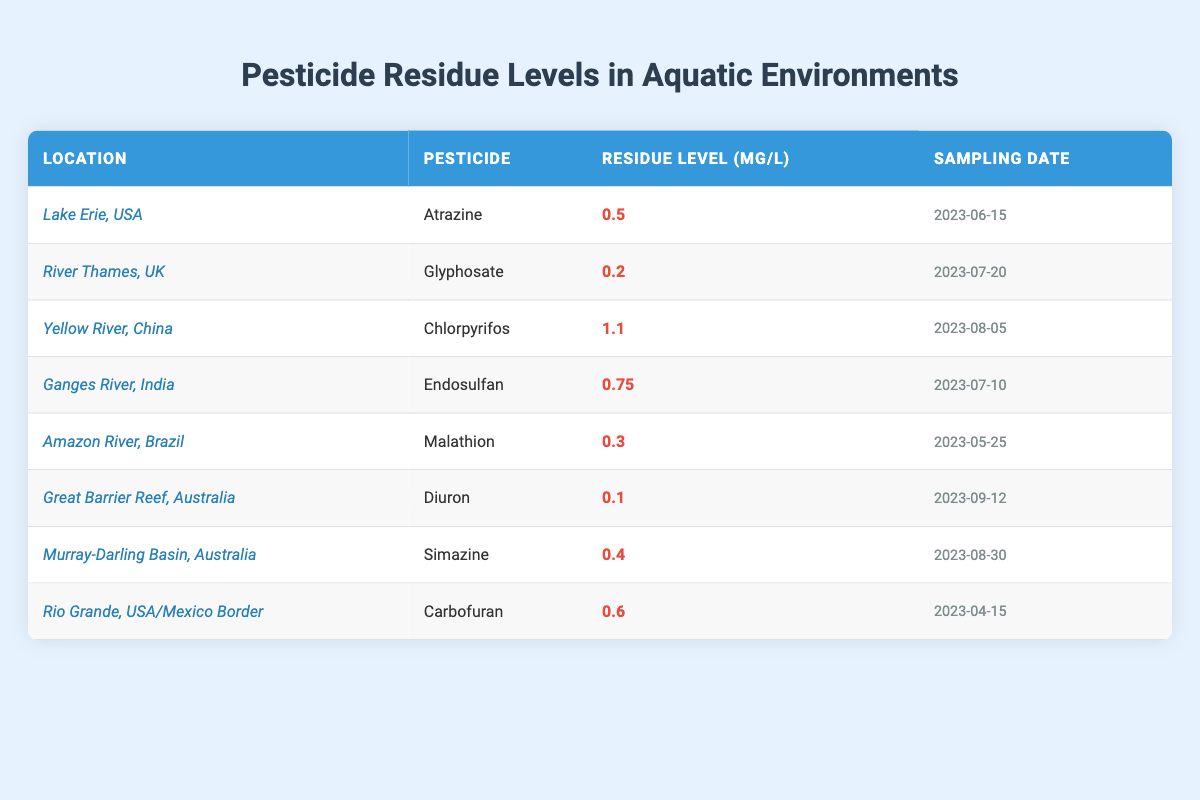What is the pesticide with the highest residue level according to the table? The table lists several pesticides along with their corresponding residue levels. By comparing the residue levels, we can see that Chlorpyrifos, which has a residue level of 1.1 mg/L, is the highest among all the pesticides listed.
Answer: Chlorpyrifos What is the residue level of Diuron in the Great Barrier Reef, Australia? The table specifically provides the residue level for Diuron at the Great Barrier Reef, which is stated to be 0.1 mg/L.
Answer: 0.1 mg/L Is there a pesticide residue level greater than 1.0 mg/L in the table? By examining the table, I can confirm that Chlorpyrifos is the only pesticide mentioned that has a residue level of 1.1 mg/L, which is indeed greater than 1.0 mg/L.
Answer: Yes What is the average residue level of pesticides listed in the table? First, we sum the residue levels: 0.5 + 0.2 + 1.1 + 0.75 + 0.3 + 0.1 + 0.4 + 0.6 = 3.85. Then, we divide this sum by the number of entries (8): 3.85 / 8 = 0.48125. Thus, the average residue level rounded to two decimal places is 0.48 mg/L.
Answer: 0.48 mg/L Which location has the lowest pesticide residue level, and what is it? Reviewing the residue levels in the table, I find that the lowest residue level is 0.1 mg/L for Diuron at the Great Barrier Reef, Australia.
Answer: Great Barrier Reef, Australia; 0.1 mg/L Was the most recent sampling conducted in August 2023? Checking the sampling dates in the table, I see that some samples were indeed collected in August (Chlorpyrifos on August 5 and Simazine on August 30), but there are more recent samples collected in September (Diuron on September 12). Therefore, not all samples were from August.
Answer: No How many pesticides have residue levels above 0.5 mg/L? By examining the residue levels, I identify that the pesticides with levels above 0.5 mg/L are Chlorpyrifos (1.1 mg/L) and Endosulfan (0.75 mg/L). This gives us a total of two pesticides meeting this criterion.
Answer: 2 